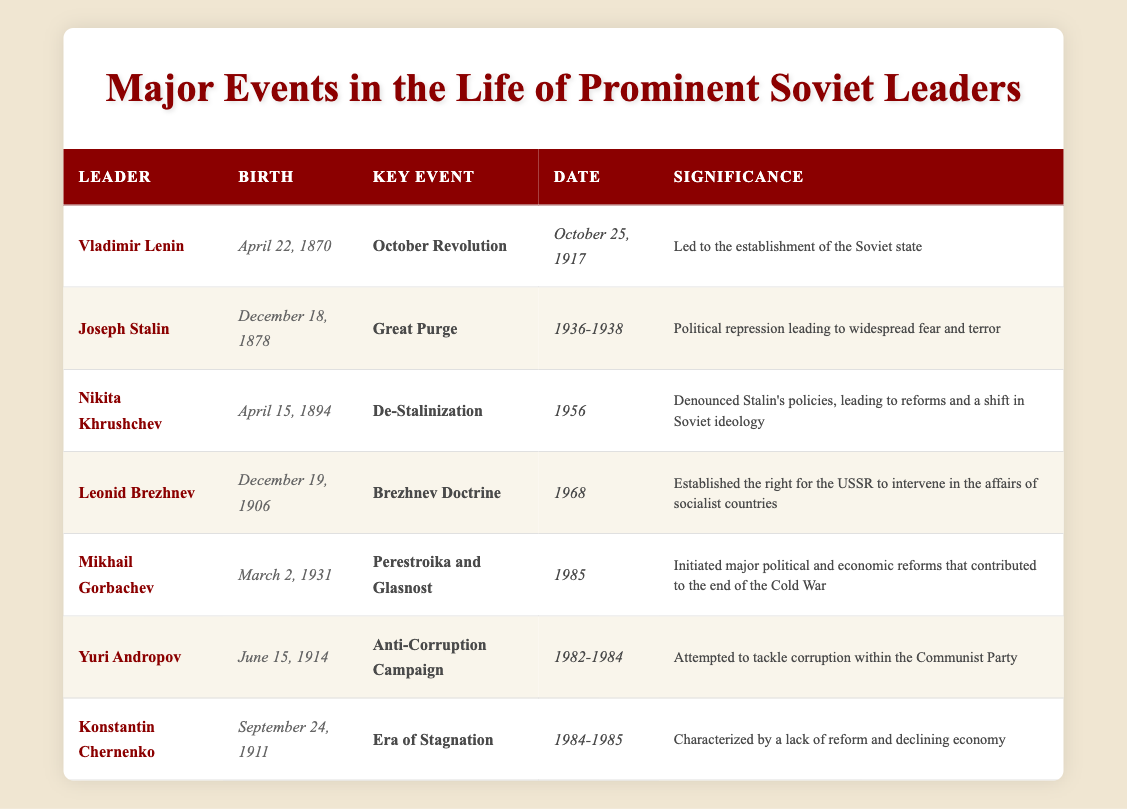What was the key event associated with Nikita Khrushchev? In the table, under the row for Nikita Khrushchev, the "Key Event" listed is "De-Stalinization."
Answer: De-Stalinization When was the Great Purge initiated by Joseph Stalin? The table indicates that the Great Purge occurred between 1936 and 1938, as provided in the "Date" column for Joseph Stalin.
Answer: 1936-1938 Which leader was born on April 22, 1870? By checking the "Birth" column for each leader, it is clear that Vladimir Lenin was born on April 22, 1870.
Answer: Vladimir Lenin What was the significance of Mikhail Gorbachev’s key event in 1985? Mikhail Gorbachev's key event, "Perestroika and Glasnost," initiated major political and economic reforms that contributed to the end of the Cold War, as noted in the "Significance" column.
Answer: End of the Cold War How many leaders were involved in events that occurred during the 1980s? The table lists two leaders associated with the 1980s: Mikhail Gorbachev (1985) and Yuri Andropov (1982-1984), which results in a total of 2 leaders involved during that decade.
Answer: 2 Did Leonid Brezhnev serve before or after Nikita Khrushchev? By examining the dates of the events and the birth years, Nikita Khrushchev's main event (1956) occurred before Leonid Brezhnev's (1968), therefore, Brezhnev served after Khrushchev.
Answer: After Which leader's key event was characterized by a lack of reform? The key event characterized by a lack of reform is under Konstantin Chernenko, labeled as "Era of Stagnation" in the table.
Answer: Konstantin Chernenko What event is associated with a significant political repression and fear? Looking at the "Key Event" column, the "Great Purge" related to Joseph Stalin is the event associated with significant political repression and widespread fear.
Answer: Great Purge Who was the last leader mentioned in the table? The last entry in the "Leader" column is "Konstantin Chernenko," making him the last leader mentioned in the table.
Answer: Konstantin Chernenko What do the dates for Yuri Andropov's key event and Konstantin Chernenko's event suggest about the timeline of leadership? Yuri Andropov's key event occurred from 1982 to 1984, while Konstantin Chernenko's lasted from 1984 to 1985, indicating they had a sequential leadership transition in the early 1980s.
Answer: Sequential leadership transition Which leader denounced Stalin's policies? The leader who denounced Stalin's policies, as mentioned in the table, is Nikita Khrushchev during the key event of "De-Stalinization."
Answer: Nikita Khrushchev 